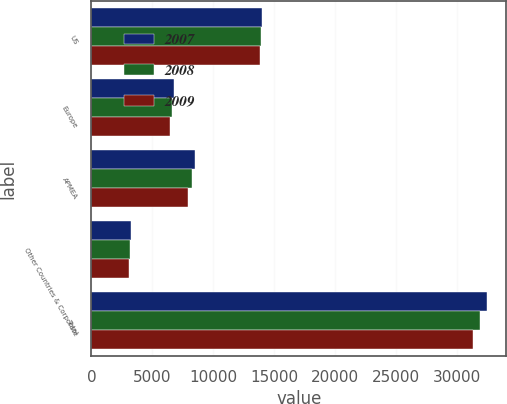<chart> <loc_0><loc_0><loc_500><loc_500><stacked_bar_chart><ecel><fcel>US<fcel>Europe<fcel>APMEA<fcel>Other Countries & Corporate<fcel>Total<nl><fcel>2007<fcel>13980<fcel>6785<fcel>8488<fcel>3225<fcel>32478<nl><fcel>2008<fcel>13918<fcel>6628<fcel>8255<fcel>3166<fcel>31967<nl><fcel>2009<fcel>13862<fcel>6480<fcel>7938<fcel>3097<fcel>31377<nl></chart> 